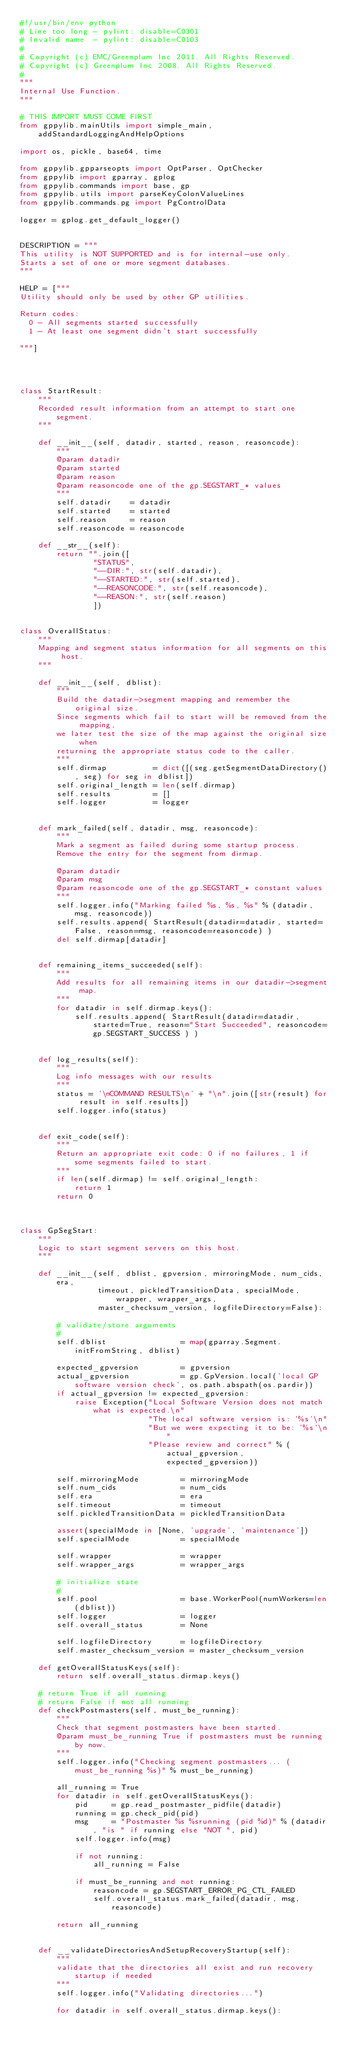Convert code to text. <code><loc_0><loc_0><loc_500><loc_500><_Python_>#!/usr/bin/env python
# Line too long - pylint: disable=C0301
# Invalid name  - pylint: disable=C0103
#
# Copyright (c) EMC/Greenplum Inc 2011. All Rights Reserved.
# Copyright (c) Greenplum Inc 2008. All Rights Reserved. 
#
"""
Internal Use Function.
"""

# THIS IMPORT MUST COME FIRST
from gppylib.mainUtils import simple_main, addStandardLoggingAndHelpOptions

import os, pickle, base64, time

from gppylib.gpparseopts import OptParser, OptChecker
from gppylib import gparray, gplog
from gppylib.commands import base, gp
from gppylib.utils import parseKeyColonValueLines
from gppylib.commands.pg import PgControlData

logger = gplog.get_default_logger()


DESCRIPTION = """
This utility is NOT SUPPORTED and is for internal-use only.
Starts a set of one or more segment databases.
"""

HELP = ["""
Utility should only be used by other GP utilities.  

Return codes:
  0 - All segments started successfully
  1 - At least one segment didn't start successfully

"""]




class StartResult:
    """
    Recorded result information from an attempt to start one segment.
    """

    def __init__(self, datadir, started, reason, reasoncode):
        """
        @param datadir
        @param started
        @param reason
        @param reasoncode one of the gp.SEGSTART_* values
        """
        self.datadir    = datadir
        self.started    = started
        self.reason     = reason
        self.reasoncode = reasoncode
    
    def __str__(self):
        return "".join([
                "STATUS", 
                "--DIR:", str(self.datadir),
                "--STARTED:", str(self.started),
                "--REASONCODE:", str(self.reasoncode),
                "--REASON:", str(self.reason)
                ])


class OverallStatus:
    """
    Mapping and segment status information for all segments on this host.
    """

    def __init__(self, dblist):
        """
        Build the datadir->segment mapping and remember the original size.
        Since segments which fail to start will be removed from the mapping, 
        we later test the size of the map against the original size when
        returning the appropriate status code to the caller.
        """
        self.dirmap          = dict([(seg.getSegmentDataDirectory(), seg) for seg in dblist])
        self.original_length = len(self.dirmap)
        self.results         = []
        self.logger          = logger


    def mark_failed(self, datadir, msg, reasoncode):
        """
        Mark a segment as failed during some startup process.
        Remove the entry for the segment from dirmap.

        @param datadir
        @param msg
        @param reasoncode one of the gp.SEGSTART_* constant values
        """
        self.logger.info("Marking failed %s, %s, %s" % (datadir, msg, reasoncode))
        self.results.append( StartResult(datadir=datadir, started=False, reason=msg, reasoncode=reasoncode) )
        del self.dirmap[datadir]


    def remaining_items_succeeded(self):
        """
        Add results for all remaining items in our datadir->segment map.
        """
        for datadir in self.dirmap.keys():
            self.results.append( StartResult(datadir=datadir, started=True, reason="Start Succeeded", reasoncode=gp.SEGSTART_SUCCESS ) )


    def log_results(self):
        """
        Log info messages with our results
        """
        status = '\nCOMMAND RESULTS\n' + "\n".join([str(result) for result in self.results])
        self.logger.info(status)


    def exit_code(self):
        """
        Return an appropriate exit code: 0 if no failures, 1 if some segments failed to start.
        """
        if len(self.dirmap) != self.original_length:
            return 1
        return 0



class GpSegStart:
    """
    Logic to start segment servers on this host.
    """

    def __init__(self, dblist, gpversion, mirroringMode, num_cids, era,
                 timeout, pickledTransitionData, specialMode, wrapper, wrapper_args,
                 master_checksum_version, logfileDirectory=False):

        # validate/store arguments
        #
        self.dblist                = map(gparray.Segment.initFromString, dblist)

        expected_gpversion         = gpversion
        actual_gpversion           = gp.GpVersion.local('local GP software version check', os.path.abspath(os.pardir))
        if actual_gpversion != expected_gpversion:
            raise Exception("Local Software Version does not match what is expected.\n"
                            "The local software version is: '%s'\n"
                            "But we were expecting it to be: '%s'\n"
                            "Please review and correct" % (actual_gpversion, expected_gpversion))

        self.mirroringMode         = mirroringMode
        self.num_cids              = num_cids
        self.era                   = era
        self.timeout               = timeout
        self.pickledTransitionData = pickledTransitionData

        assert(specialMode in [None, 'upgrade', 'maintenance'])
        self.specialMode           = specialMode

        self.wrapper               = wrapper
        self.wrapper_args          = wrapper_args

        # initialize state
        #
        self.pool                  = base.WorkerPool(numWorkers=len(dblist))
        self.logger                = logger
        self.overall_status        = None

        self.logfileDirectory      = logfileDirectory
        self.master_checksum_version = master_checksum_version

    def getOverallStatusKeys(self):
        return self.overall_status.dirmap.keys()

    # return True if all running
    # return False if not all running
    def checkPostmasters(self, must_be_running):
        """
        Check that segment postmasters have been started.
        @param must_be_running True if postmasters must be running by now.
        """
        self.logger.info("Checking segment postmasters... (must_be_running %s)" % must_be_running)

        all_running = True
        for datadir in self.getOverallStatusKeys():
            pid     = gp.read_postmaster_pidfile(datadir)
            running = gp.check_pid(pid)
            msg     = "Postmaster %s %srunning (pid %d)" % (datadir, "is " if running else "NOT ", pid)
            self.logger.info(msg)

            if not running:
                all_running = False

            if must_be_running and not running:
                reasoncode = gp.SEGSTART_ERROR_PG_CTL_FAILED
                self.overall_status.mark_failed(datadir, msg, reasoncode)

        return all_running


    def __validateDirectoriesAndSetupRecoveryStartup(self):
        """
        validate that the directories all exist and run recovery startup if needed
        """
        self.logger.info("Validating directories...")

        for datadir in self.overall_status.dirmap.keys():</code> 